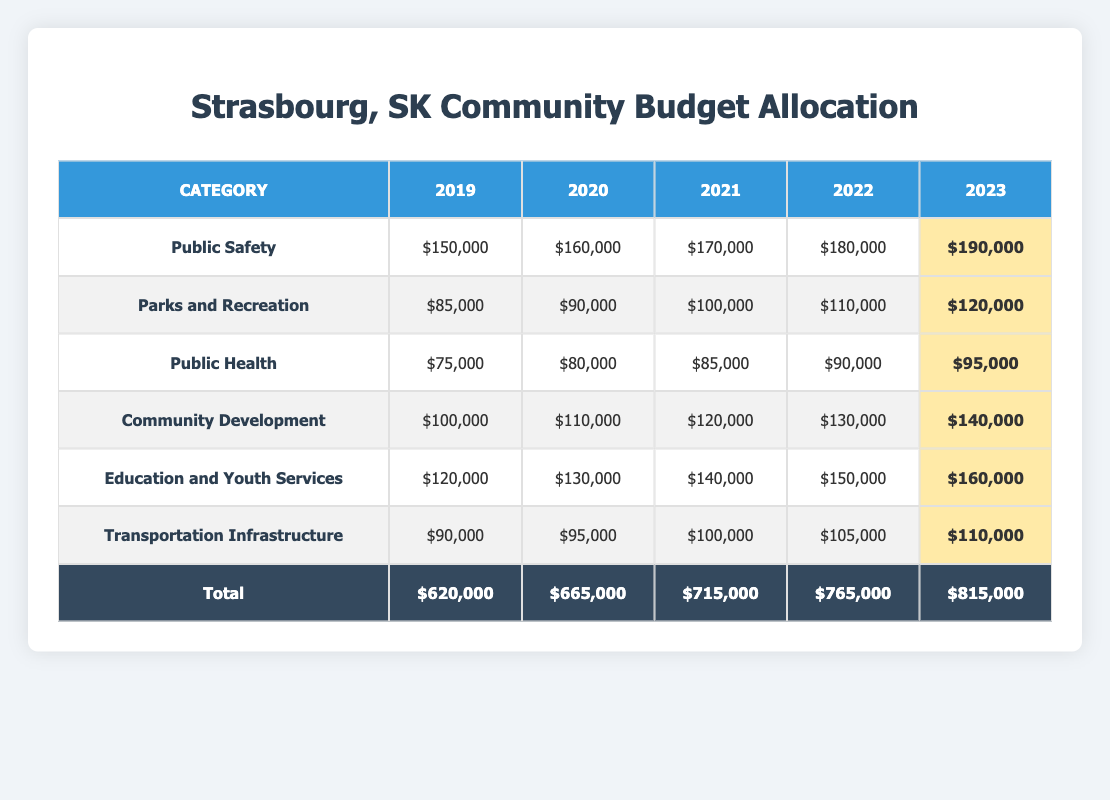What was the budget for Public Health in 2022? The table shows that the budget allocation for Public Health in 2022 is $90,000.
Answer: $90,000 Which category received the highest budget in 2023? By looking at the table for the year 2023, the category with the highest budget is Education and Youth Services with $160,000.
Answer: Education and Youth Services What is the total budget allocated for Transportation Infrastructure from 2019 to 2023? The total budget for Transportation Infrastructure over the years is calculated as follows: $90,000 (2019) + $95,000 (2020) + $100,000 (2021) + $105,000 (2022) + $110,000 (2023) = $500,000.
Answer: $500,000 By how much did the budget for Community Development increase from 2020 to 2022? The budget for Community Development in 2022 is $130,000, and in 2020 it was $110,000. The increase is calculated as $130,000 - $110,000 = $20,000.
Answer: $20,000 Is the budget for Parks and Recreation higher in 2023 than in 2020? In 2023, the budget for Parks and Recreation is $120,000, while in 2020 it was $90,000. Since $120,000 is greater than $90,000, the statement is true.
Answer: Yes What is the average budget allocation for Public Safety over the five years? The budgets for Public Safety over the five years are $150,000, $160,000, $170,000, $180,000, and $190,000. Summing these gives $850,000, and dividing by 5 yields an average of $170,000.
Answer: $170,000 Did the total budget allocation increase every year from 2019 to 2023? Checking the total budget for each year: $620,000 (2019), $665,000 (2020), $715,000 (2021), $765,000 (2022), and $815,000 (2023), it shows that each year's total is greater than the previous year. Therefore, yes, it increased every year.
Answer: Yes Which category had the least amount allocated in 2019? In 2019, the categories had the following allocations: Public Safety ($150,000), Parks and Recreation ($85,000), Public Health ($75,000), Community Development ($100,000), Education and Youth Services ($120,000), and Transportation Infrastructure ($90,000). Public Health had the least at $75,000.
Answer: Public Health How much more was allocated to Education and Youth Services in 2023 compared to 2019? The allocation for Education and Youth Services in 2023 is $160,000, and in 2019 it was $120,000. The difference is $160,000 - $120,000 = $40,000.
Answer: $40,000 What was the total budget for the year 2023 compared to 2022? The total budget for 2022 is $765,000 and for 2023 it is $815,000. The increase in total budget from 2022 to 2023 is $815,000 - $765,000 = $50,000.
Answer: $50,000 Which category saw the largest percentage increase from 2019 to 2023? To determine the category with the largest percentage increase, we calculate the percentage change for each category from 2019 to 2023. Public Safety went from $150,000 to $190,000, an increase of 26.67%. Education and Youth Services went from $120,000 to $160,000, an increase of 33.33%. Therefore, Education and Youth Services saw the largest percentage increase.
Answer: Education and Youth Services 